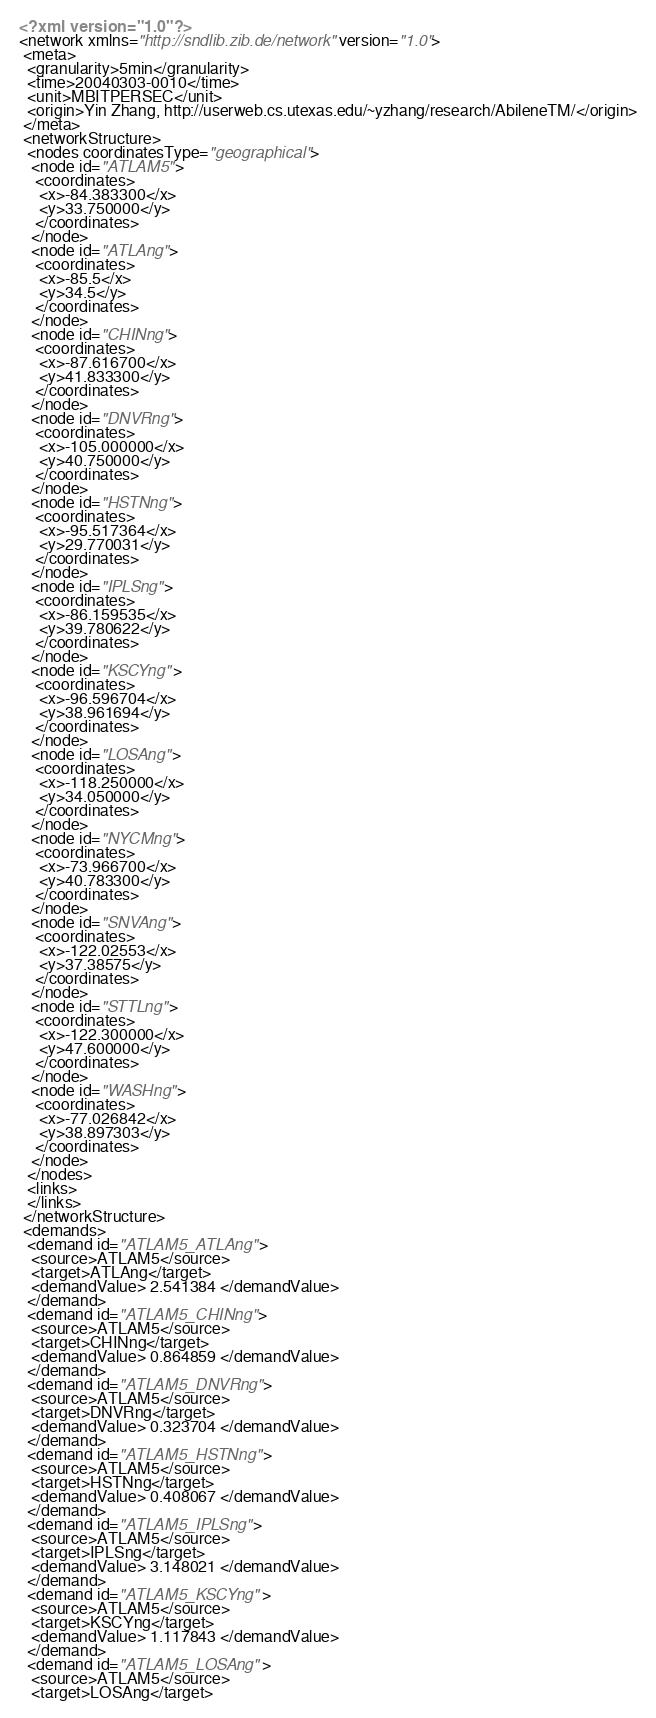Convert code to text. <code><loc_0><loc_0><loc_500><loc_500><_XML_><?xml version="1.0"?>
<network xmlns="http://sndlib.zib.de/network" version="1.0">
 <meta>
  <granularity>5min</granularity>
  <time>20040303-0010</time>
  <unit>MBITPERSEC</unit>
  <origin>Yin Zhang, http://userweb.cs.utexas.edu/~yzhang/research/AbileneTM/</origin>
 </meta>
 <networkStructure>
  <nodes coordinatesType="geographical">
   <node id="ATLAM5">
    <coordinates>
     <x>-84.383300</x>
     <y>33.750000</y>
    </coordinates>
   </node>
   <node id="ATLAng">
    <coordinates>
     <x>-85.5</x>
     <y>34.5</y>
    </coordinates>
   </node>
   <node id="CHINng">
    <coordinates>
     <x>-87.616700</x>
     <y>41.833300</y>
    </coordinates>
   </node>
   <node id="DNVRng">
    <coordinates>
     <x>-105.000000</x>
     <y>40.750000</y>
    </coordinates>
   </node>
   <node id="HSTNng">
    <coordinates>
     <x>-95.517364</x>
     <y>29.770031</y>
    </coordinates>
   </node>
   <node id="IPLSng">
    <coordinates>
     <x>-86.159535</x>
     <y>39.780622</y>
    </coordinates>
   </node>
   <node id="KSCYng">
    <coordinates>
     <x>-96.596704</x>
     <y>38.961694</y>
    </coordinates>
   </node>
   <node id="LOSAng">
    <coordinates>
     <x>-118.250000</x>
     <y>34.050000</y>
    </coordinates>
   </node>
   <node id="NYCMng">
    <coordinates>
     <x>-73.966700</x>
     <y>40.783300</y>
    </coordinates>
   </node>
   <node id="SNVAng">
    <coordinates>
     <x>-122.02553</x>
     <y>37.38575</y>
    </coordinates>
   </node>
   <node id="STTLng">
    <coordinates>
     <x>-122.300000</x>
     <y>47.600000</y>
    </coordinates>
   </node>
   <node id="WASHng">
    <coordinates>
     <x>-77.026842</x>
     <y>38.897303</y>
    </coordinates>
   </node>
  </nodes>
  <links>
  </links>
 </networkStructure>
 <demands>
  <demand id="ATLAM5_ATLAng">
   <source>ATLAM5</source>
   <target>ATLAng</target>
   <demandValue> 2.541384 </demandValue>
  </demand>
  <demand id="ATLAM5_CHINng">
   <source>ATLAM5</source>
   <target>CHINng</target>
   <demandValue> 0.864859 </demandValue>
  </demand>
  <demand id="ATLAM5_DNVRng">
   <source>ATLAM5</source>
   <target>DNVRng</target>
   <demandValue> 0.323704 </demandValue>
  </demand>
  <demand id="ATLAM5_HSTNng">
   <source>ATLAM5</source>
   <target>HSTNng</target>
   <demandValue> 0.408067 </demandValue>
  </demand>
  <demand id="ATLAM5_IPLSng">
   <source>ATLAM5</source>
   <target>IPLSng</target>
   <demandValue> 3.148021 </demandValue>
  </demand>
  <demand id="ATLAM5_KSCYng">
   <source>ATLAM5</source>
   <target>KSCYng</target>
   <demandValue> 1.117843 </demandValue>
  </demand>
  <demand id="ATLAM5_LOSAng">
   <source>ATLAM5</source>
   <target>LOSAng</target></code> 